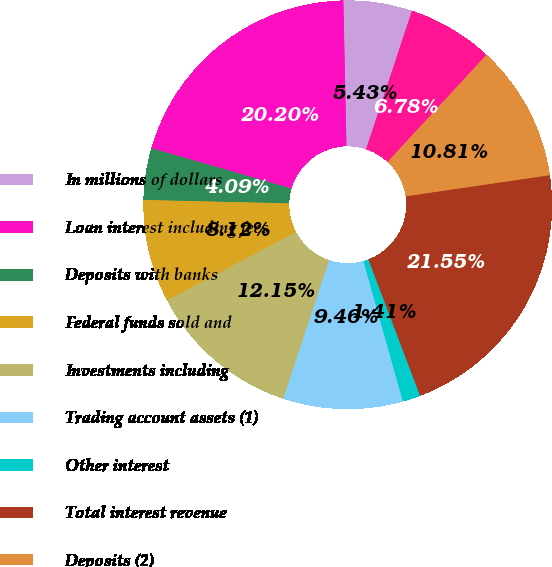Convert chart to OTSL. <chart><loc_0><loc_0><loc_500><loc_500><pie_chart><fcel>In millions of dollars<fcel>Loan interest including fees<fcel>Deposits with banks<fcel>Federal funds sold and<fcel>Investments including<fcel>Trading account assets (1)<fcel>Other interest<fcel>Total interest revenue<fcel>Deposits (2)<fcel>Federal funds purchased and<nl><fcel>5.43%<fcel>20.2%<fcel>4.09%<fcel>8.12%<fcel>12.15%<fcel>9.46%<fcel>1.41%<fcel>21.55%<fcel>10.81%<fcel>6.78%<nl></chart> 